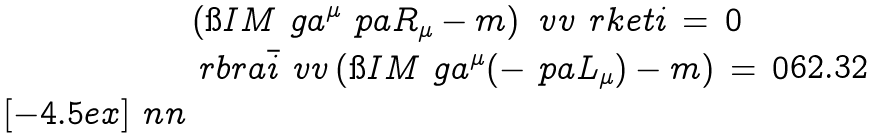Convert formula to latex. <formula><loc_0><loc_0><loc_500><loc_500>& \left ( \i I M \ g a ^ { \mu } \ p a R _ { \mu } - m \right ) \ v v \ r k e t { i } \, = \, 0 \\ & \ r b r a { \bar { i } } \ v v \left ( \i I M \ g a ^ { \mu } ( - \ p a L _ { \mu } ) - m \right ) \, = \, 0 \\ [ - 4 . 5 e x ] \ n n</formula> 